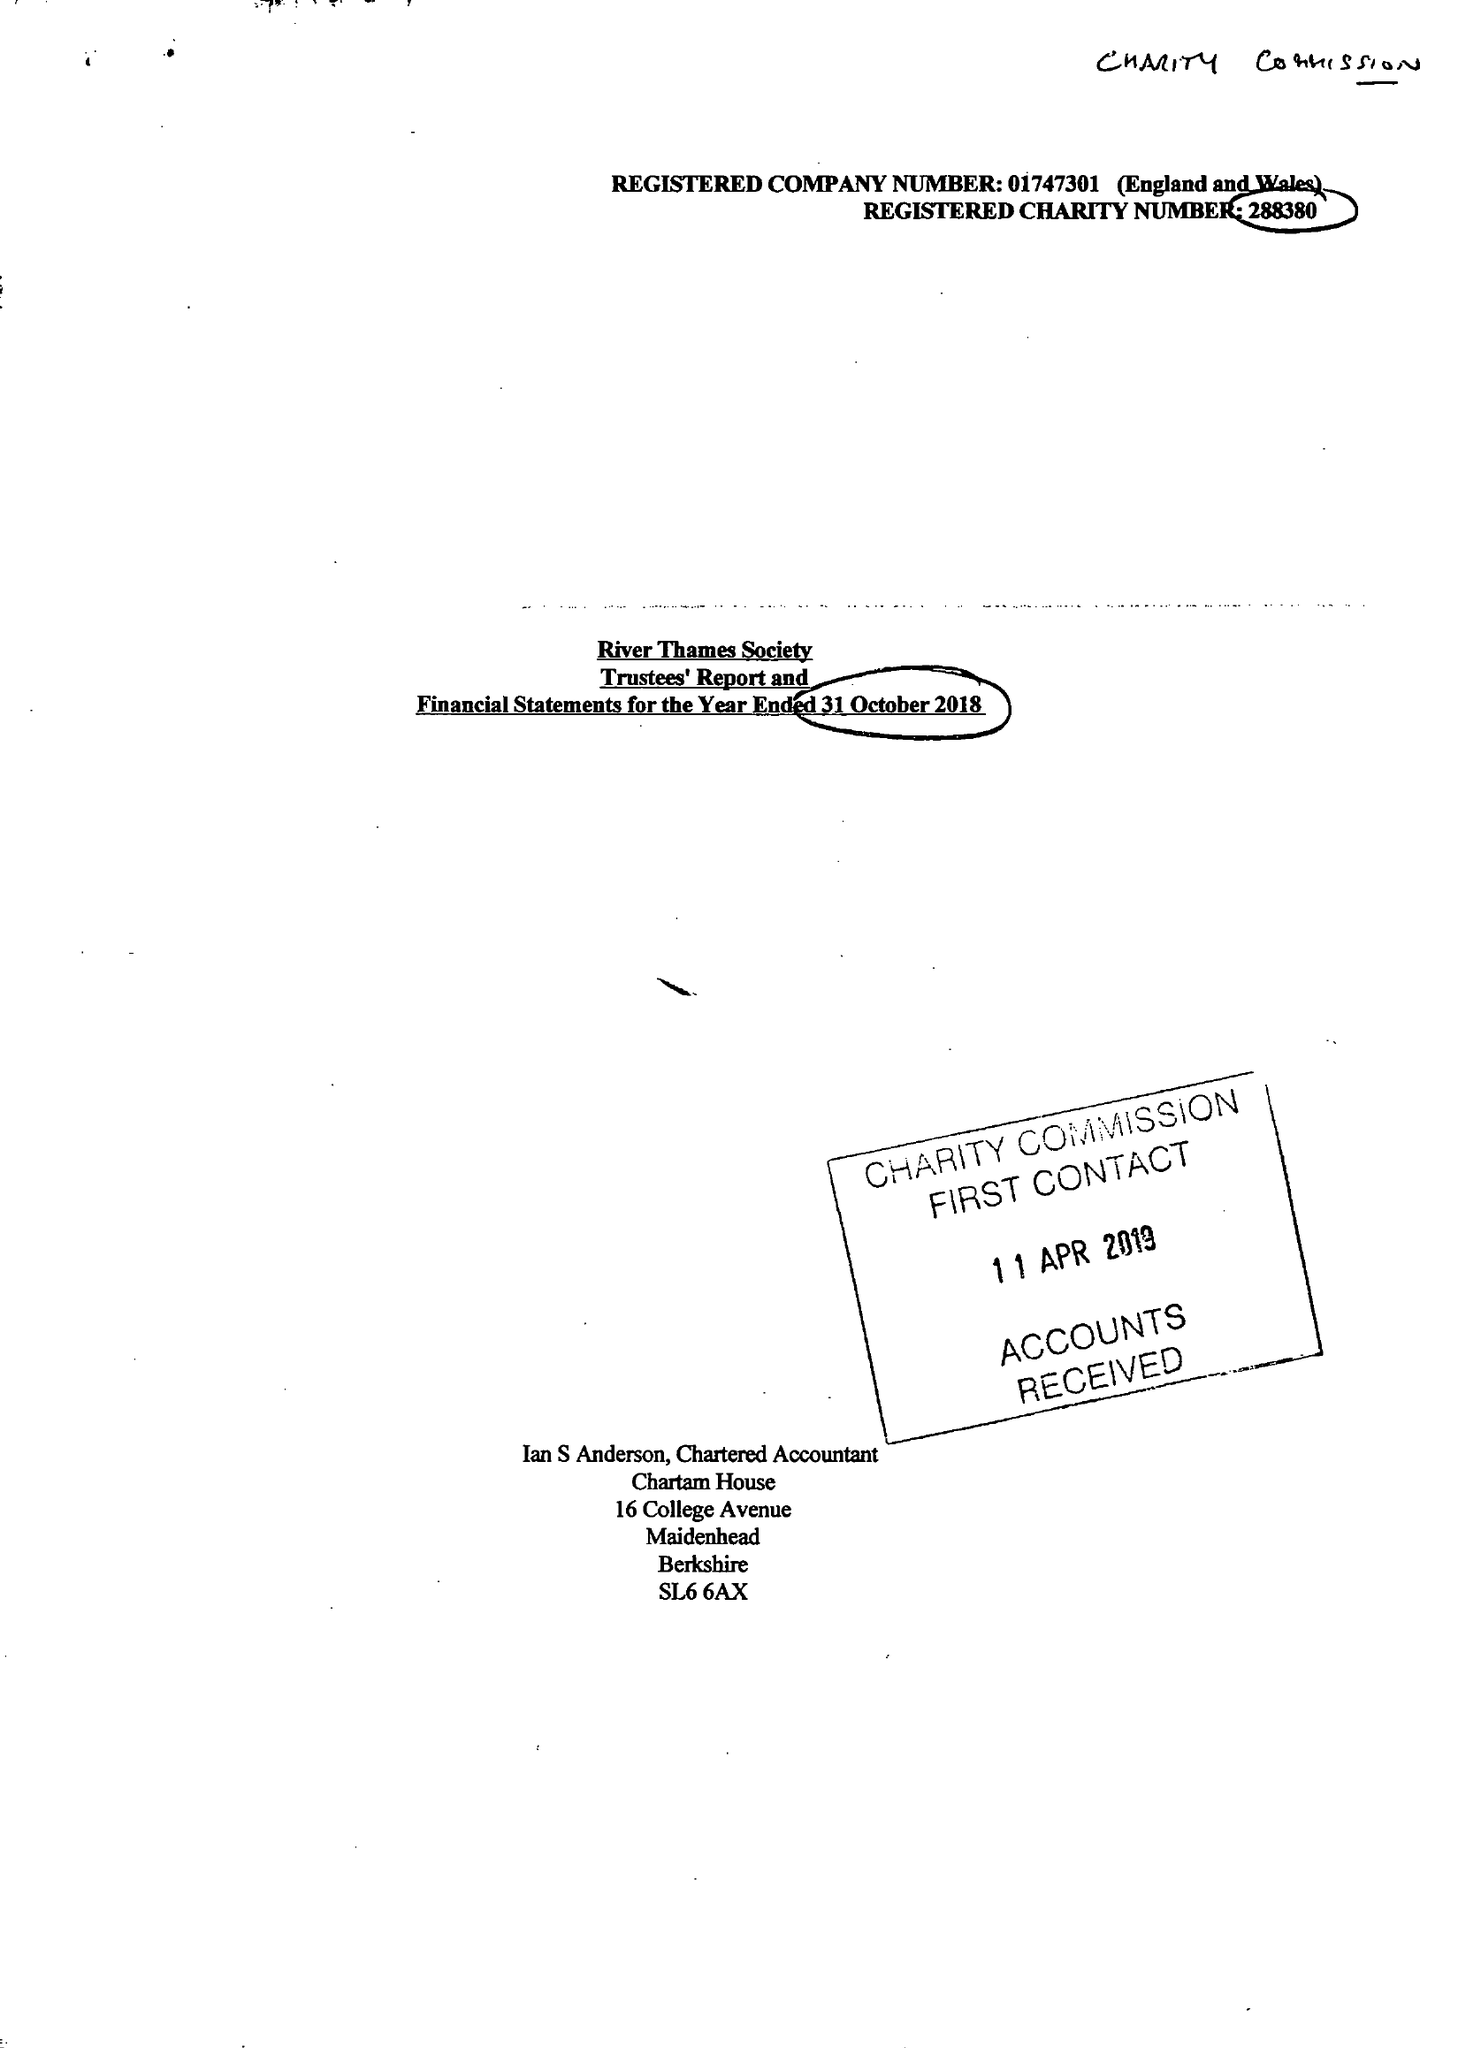What is the value for the address__post_town?
Answer the question using a single word or phrase. WINDSOR 